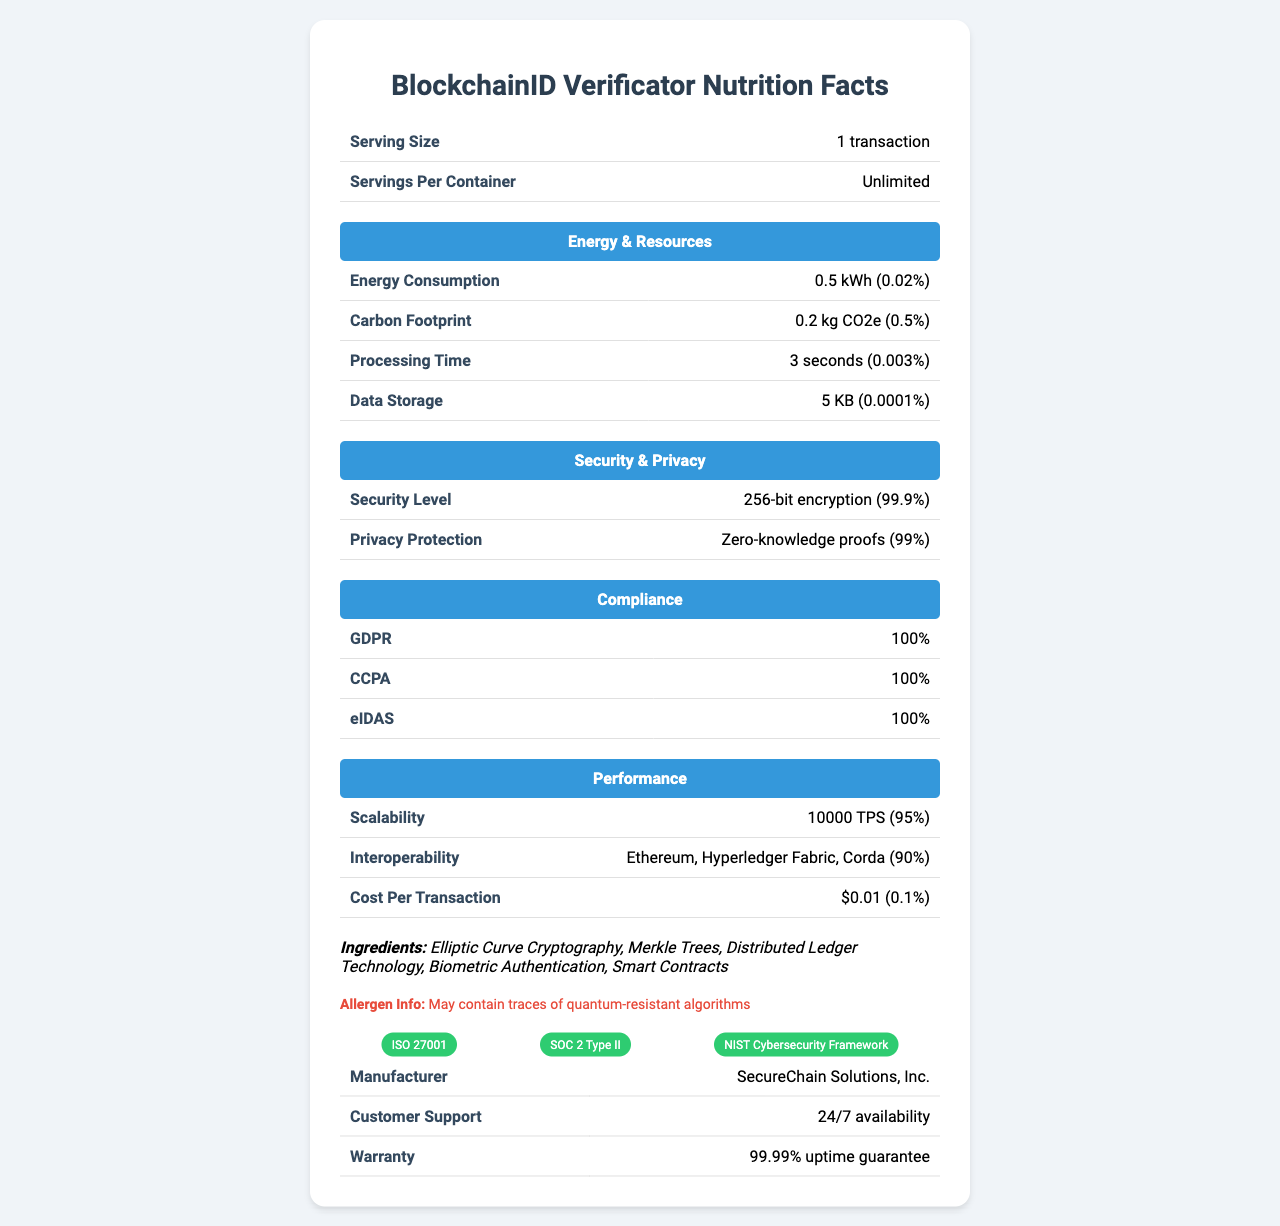what is the serving size of the BlockchainID Verificator? According to the document, the serving size is specified as "1 transaction".
Answer: 1 transaction how much energy does one transaction of BlockchainID Verificator consume? The document states that the energy consumption per transaction is 0.5 kWh.
Answer: 0.5 kWh what compliance standards does the BlockchainID Verificator meet? The document lists GDPR, CCPA, and eIDAS as the compliance standards met by the BlockchainID Verificator.
Answer: GDPR, CCPA, eIDAS what cryptographic technique is used in BlockchainID Verificator? According to the ingredients section in the document, Elliptic Curve Cryptography is used.
Answer: Elliptic Curve Cryptography how long does it take to process one transaction in BlockchainID Verificator? The processing time per transaction is listed as 3 seconds in the document.
Answer: 3 seconds which of the following platforms is BlockchainID Verificator compatible with? A. Ethereum B. Hyperledger Fabric C. Corda D. All of the above The document mentions compatibility with Ethereum, Hyperledger Fabric, and Corda, making the answer "All of the above."
Answer: D. All of the above what is the cost per transaction for using BlockchainID Verificator? A. $0.01 B. $0.05 C. $0.10 D. $1.00 The document specifies that the cost per transaction is $0.01.
Answer: A. $0.01 does the BlockchainID Verificator use quantum-resistant algorithms? The allergen information section lists "May contain traces of quantum-resistant algorithms," indicating that it may include these.
Answer: May contain traces of quantum-resistant algorithms is Security Level of BlockchainID Verificator high? The document mentions a security level of 256-bit encryption, which is considered very secure.
Answer: Yes summarize the main idea of the document. The document gives a comprehensive overview of the BlockchainID Verificator's various performance metrics and features in a structured label format.
Answer: The document provides a detailed 'Nutrition Facts' style label for the BlockchainID Verificator, highlighting its energy consumption, carbon footprint, processing time, data storage requirements, security features, privacy protection, compliance standards, scalability, interoperability, cost per transaction, and ingredients. It also mentions customer support availability and certifications. what is the impact of BlockchainID Verificator on daily carbon footprint? The document only provides the carbon footprint per transaction (0.2 kg CO2e) but doesn't provide daily usage or total impact details, making it impossible to determine the daily carbon footprint.
Answer: Not enough information 